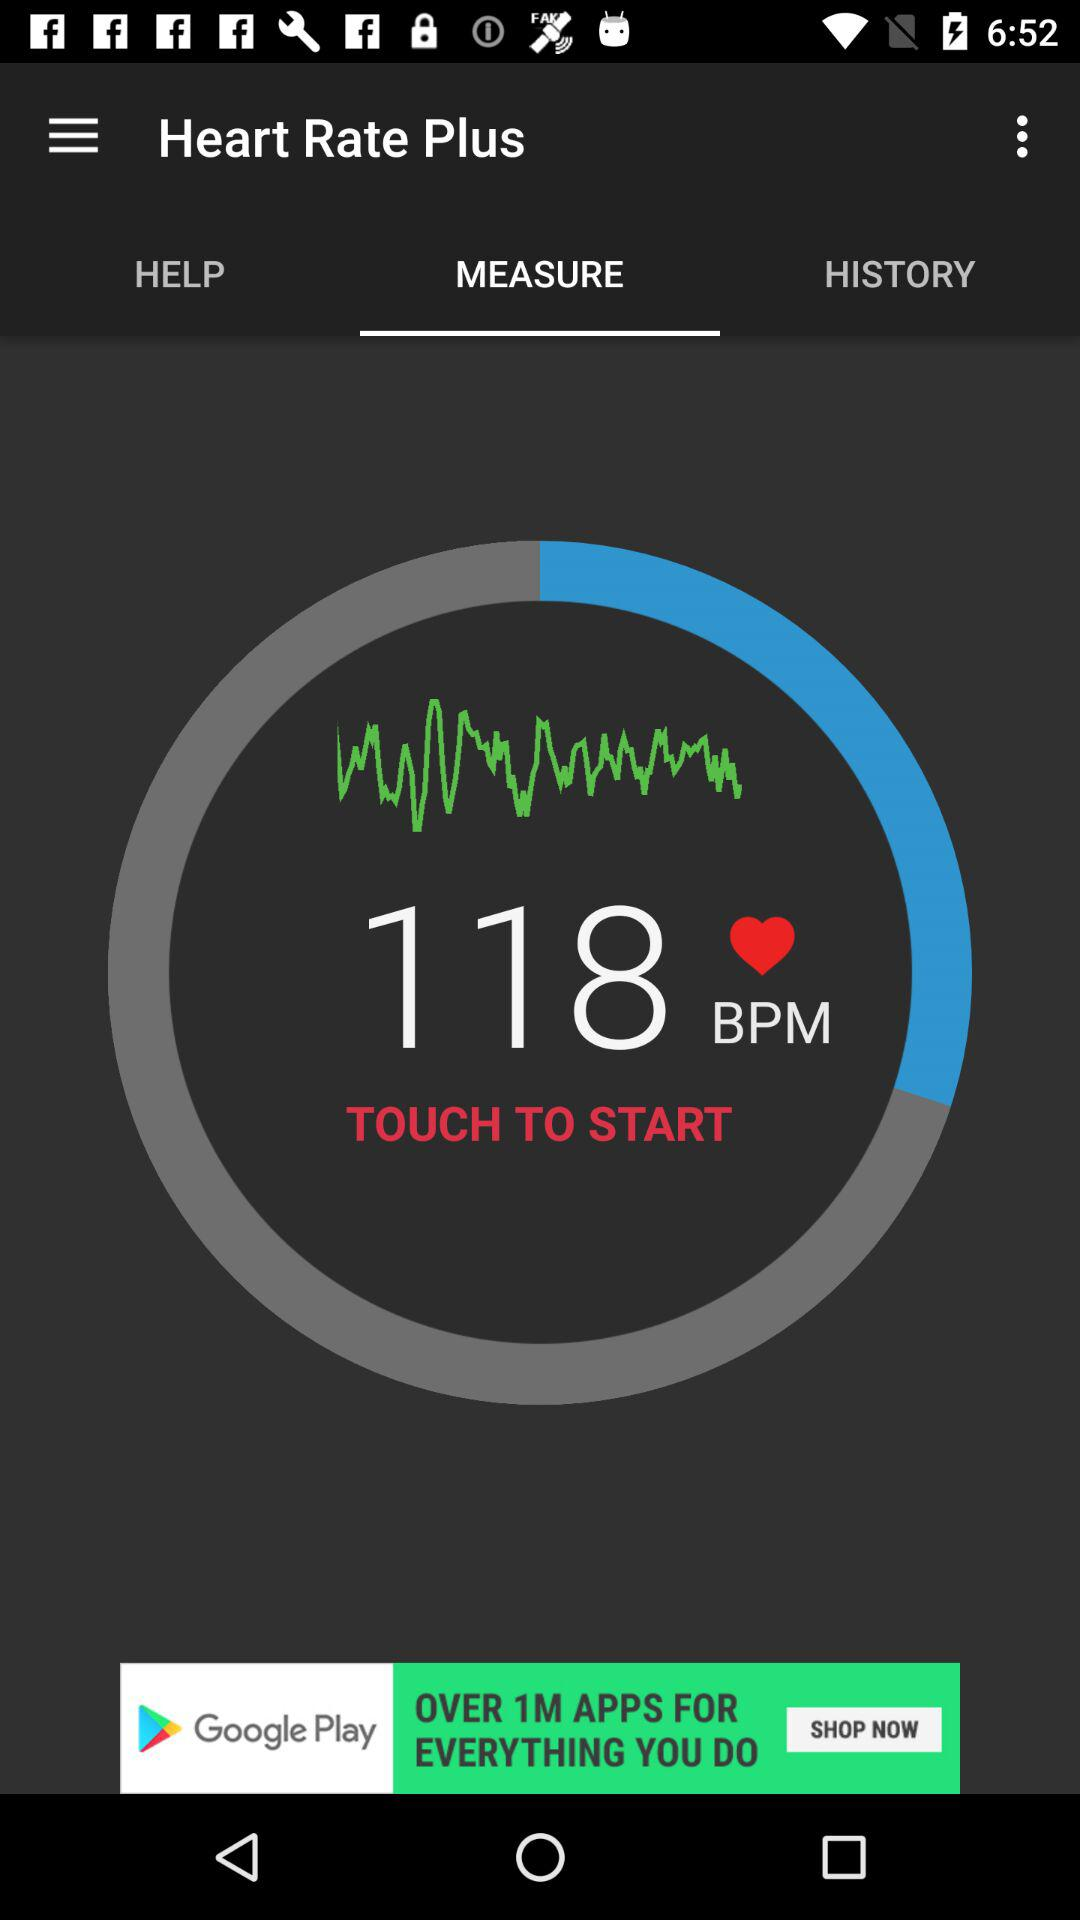What is the heart rate shown on the screen? The heart rate is 118 bpm. 